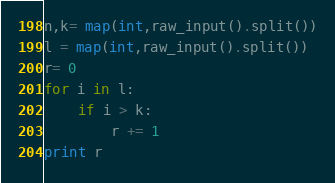<code> <loc_0><loc_0><loc_500><loc_500><_Python_>n,k= map(int,raw_input().split())
l = map(int,raw_input().split())
r= 0
for i in l:
    if i > k:
        r += 1
print r
</code> 